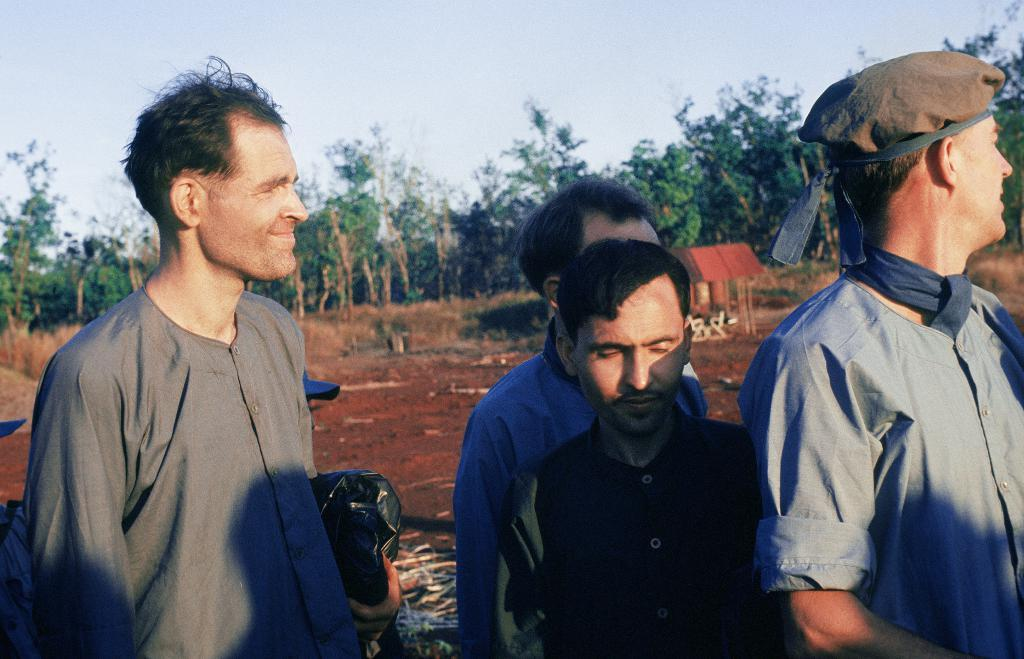What is happening in the image? There are people standing in the image. What can be seen in the background of the image? There are trees visible in the background of the image. What type of club is being used by the people in the image? There is no club visible in the image; the people are simply standing. 